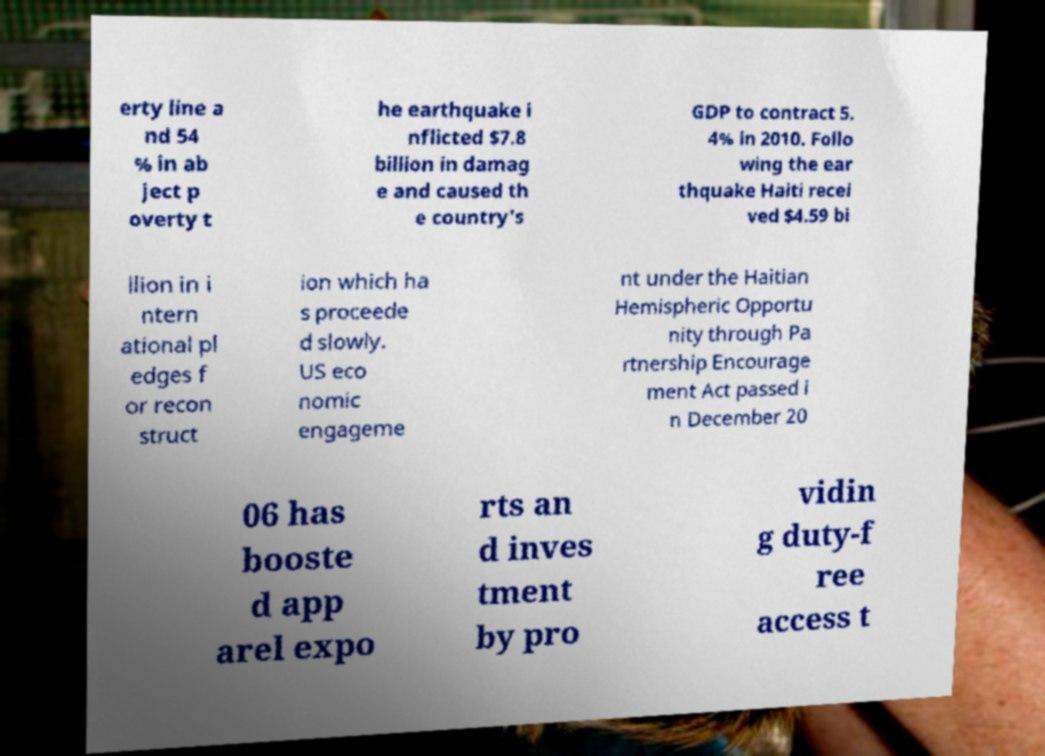Could you extract and type out the text from this image? erty line a nd 54 % in ab ject p overty t he earthquake i nflicted $7.8 billion in damag e and caused th e country's GDP to contract 5. 4% in 2010. Follo wing the ear thquake Haiti recei ved $4.59 bi llion in i ntern ational pl edges f or recon struct ion which ha s proceede d slowly. US eco nomic engageme nt under the Haitian Hemispheric Opportu nity through Pa rtnership Encourage ment Act passed i n December 20 06 has booste d app arel expo rts an d inves tment by pro vidin g duty-f ree access t 